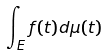<formula> <loc_0><loc_0><loc_500><loc_500>\int _ { E } f ( t ) d \mu ( t )</formula> 